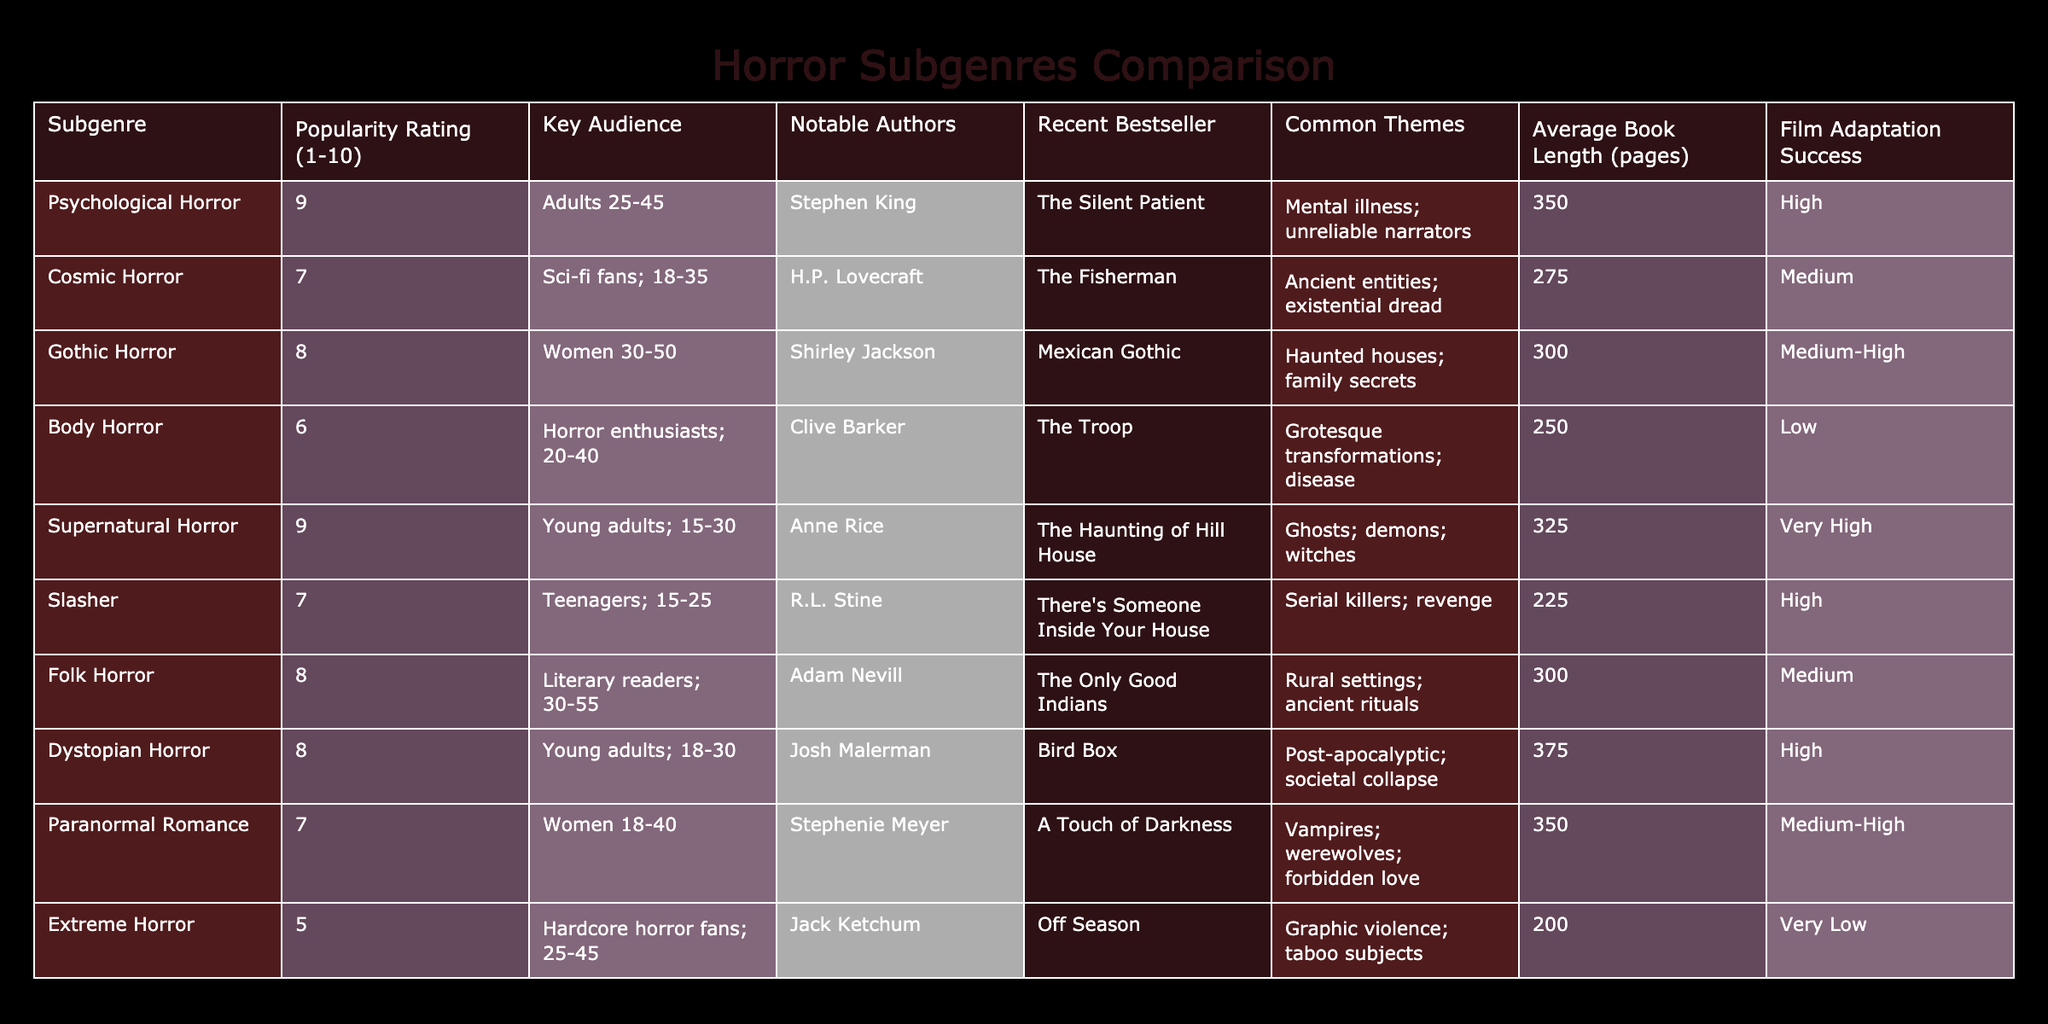What is the popularity rating of Psychological Horror? The table shows that the popularity rating for Psychological Horror is listed under the corresponding column. According to the data, it is rated as 9.
Answer: 9 Which horror subgenre has the lowest film adaptation success? By examining the column for film adaptation success, we see the subgenre with the lowest rating is Extreme Horror, which has a "Very Low" success listed in the table.
Answer: Extreme Horror What is the average book length for Supernatural Horror and Gothic Horror combined? To find the average length, we first note the average book lengths: Supernatural Horror has 325 pages and Gothic Horror has 300 pages. Adding these two gives us 625 pages. Dividing by 2: 625/2 equals 312.5.
Answer: 312.5 Is there a subgenre with a popularity rating of 6 or lower? Looking at the popularity ratings in the table, Body Horror has a rating of 6, which indicates that there is at least one subgenre below the threshold of 6. Thus, the answer is yes.
Answer: Yes Which subgenre appeals to the youngest audience and what is its popularity rating? The table lists Supernatural Horror as the subgenre that appeals to young adults aged 15-30. The corresponding popularity rating for this subgenre is 9, which is the highest for this age group.
Answer: Supernatural Horror; 9 What common theme is shared between Gothic Horror and Folk Horror? From the provided data, Gothic Horror includes the theme of haunted houses and family secrets, while Folk Horror features rural settings and ancient rituals. Both explore family and ancestral connections, albeit through different contexts. Thus, the shared theme is exploration of familial and ancient ties.
Answer: Shared theme of family/ancestral connections What is the difference in popularity ratings between Dystopian Horror and Extreme Horror? The popularity rating for Dystopian Horror is 8, and for Extreme Horror, it is 5. To find the difference, we subtract the lower rating from the higher one: 8 - 5 = 3.
Answer: 3 Which subgenre has notable authors known for psychological elements? The subgenres listed include Psychological Horror and Gothic Horror. Stephen King is noted for Psychological Horror, while Shirley Jackson is known for Gothic Horror. Both authors are renowned for crafting psychological elements.
Answer: Psychological Horror and Gothic Horror How many horror subgenres have a popularity rating of 8 or higher? By checking the table, we see that Psychological Horror, Gothic Horror, Supernatural Horror, Dystopian Horror, and Folk Horror all have a rating of 8 or above. That totals to five subgenres with high popularity ratings.
Answer: 5 